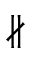Convert formula to latex. <formula><loc_0><loc_0><loc_500><loc_500>\nparallel</formula> 